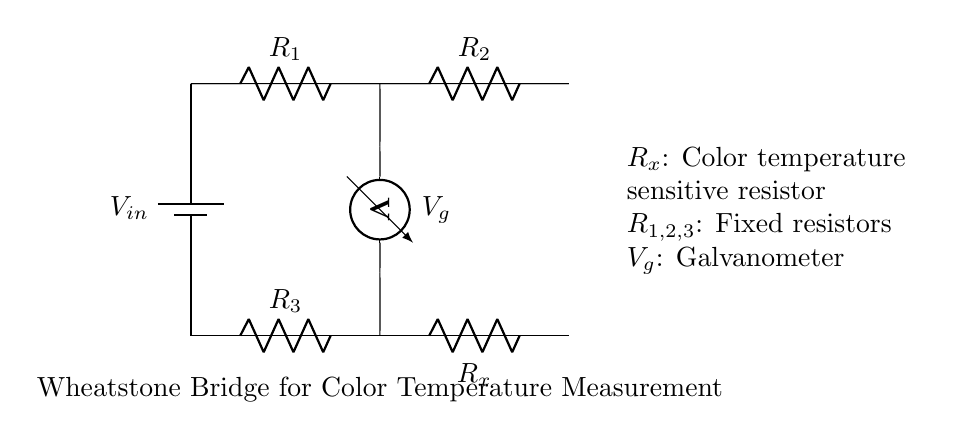What is the input voltage in this circuit? The input voltage is labeled as \( V_{in} \) in the circuit, indicating it is the voltage supplied to the Wheatstone Bridge.
Answer: \( V_{in} \) How many resistors are present in this circuit? The circuit shows four resistors: \( R_1, R_2, R_3, \) and \( R_x \). Thus, the total count of resistors is four.
Answer: 4 What does the galvanometer measure? The galvanometer in the circuit is represented as \( V_g \), which measures the voltage across the bridge and indicates balance between the resistors.
Answer: Voltage What is the role of \( R_x \) in the circuit? \( R_x \) is defined as a color temperature sensitive resistor, meaning it varies its resistance based on color temperature, influencing the balance of the bridge.
Answer: Color temperature If \( R_1 \) and \( R_2 \) are equal, what can be inferred about \( R_3 \) and \( R_x \)? If \( R_1 \) equals \( R_2 \) and the bridge is balanced (indicated by a zero reading on the galvanometer), it implies that \( R_3 \) must equal \( R_x \) to maintain equilibrium in the circuit.
Answer: \( R_3 = R_x \) What happens when \( R_x \) changes its resistance? When \( R_x \) changes its resistance due to variations in color temperature, it disrupts the balance of the Wheatstone Bridge, resulting in a non-zero voltage reading on the galvanometer.
Answer: Disrupts balance Which resistors are considered fixed in this circuit? The resistors \( R_1, R_2, \) and \( R_3 \) are indicated as fixed resistors, meaning their resistance values do not change during operation.
Answer: \( R_1, R_2, R_3 \) 